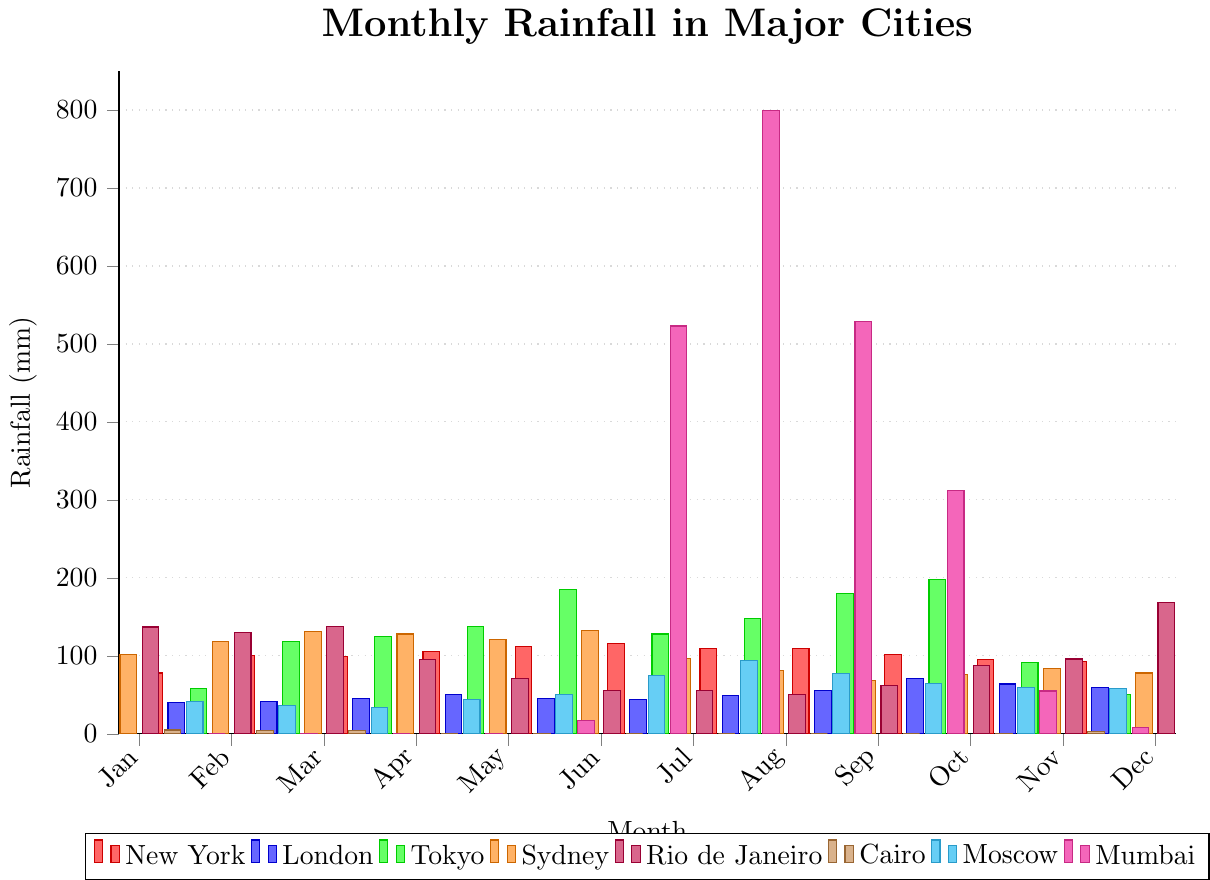Which city has the highest rainfall in July? Comparing the heights of the bars for July, Mumbai's bar is the tallest.
Answer: Mumbai Which city has the lowest rainfall in June? Comparing the heights of the bars for June, Cairo's bar is the shortest.
Answer: Cairo How much more rainfall does New York have in August compared to November? New York's rainfall in August is 110 mm, and in November it is 95 mm. The difference is 110 - 95 = 15 mm.
Answer: 15 mm Which months have the highest and lowest rainfall for Tokyo? Tokyo has the highest rainfall in October and the lowest in January.
Answer: Highest: October, Lowest: January What is the average monthly rainfall in London? Summing London's monthly rainfalls gives 625 mm. Dividing by 12 (months) gives an average of 625 / 12 = 52.08 mm.
Answer: 52.08 mm In which month does Sydney receive the most rainfall? The tallest bar for Sydney is in March with 131 mm of rainfall.
Answer: March Compare the total rainfall in Rio de Janeiro for the first and second halves of the year. Summing January to June: 137 + 130 + 138 + 95 + 71 + 56 = 627 mm. Summing July to December: 56 + 50 + 62 + 88 + 96 + 169 = 521 mm.
Answer: First half: 627 mm, Second half: 521 mm During which months does Cairo experience any rainfall? The bars for Cairo have non-zero heights in January, February, March, April, May, October, November, and December.
Answer: Jan, Feb, Mar, Apr, May, Oct, Nov, Dec What is the difference in rainfall between Moscow and New York in December? Moscow's rainfall in December is 52 mm, and New York's is 93 mm. The difference is 93 - 52 = 41 mm.
Answer: 41 mm Which city experiences the most dramatic change in rainfall between two consecutive months? The most dramatic change is observed in Mumbai between May (17 mm) and June (523 mm) with a change of 523 - 17 = 506 mm.
Answer: Mumbai 